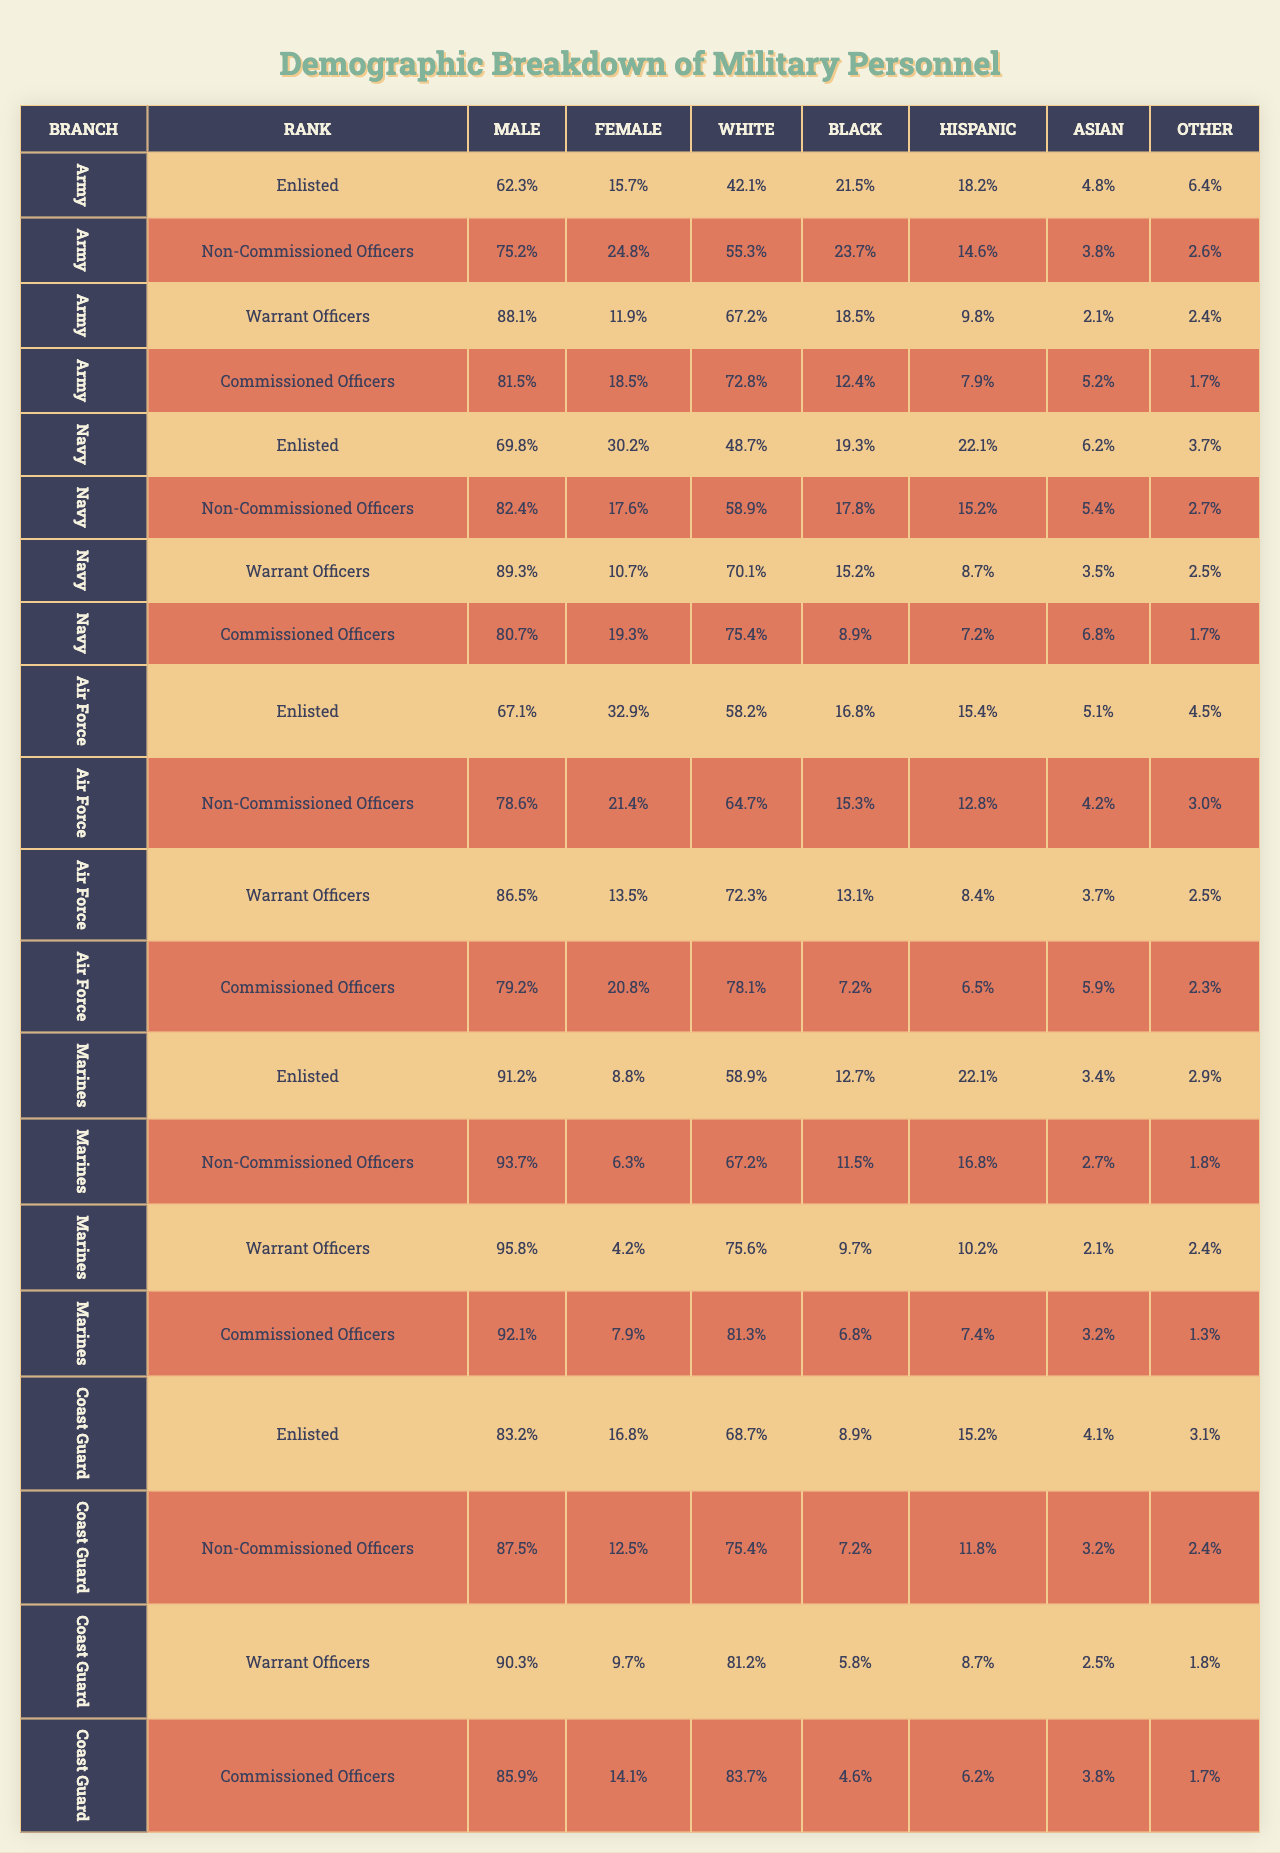What percentage of Army personnel are Female in the Enlisted rank? In the table under the Army branch and Enlisted rank, the Female percentage is 15.7%.
Answer: 15.7% Which branch has the highest percentage of Male personnel in the Warrant Officers rank? From the table, the Marines have the highest Male percentage in the Warrant Officers rank with 95.8%.
Answer: 95.8% Is the percentage of White personnel in the Navy higher than in the Coast Guard in the Non-Commissioned Officers rank? For Non-Commissioned Officers, the Navy has 58.9% White personnel while the Coast Guard has 75.4%. Therefore, this statement is false.
Answer: No Which rank in the Army has the lowest percentage of Female personnel? In the Army, the Warrant Officers rank has the lowest Female percentage at 11.9%.
Answer: 11.9% What is the combined percentage of Black and Hispanic personnel in the Air Force's Enlisted rank? The Enlisted rank in the Air Force has 16.8% Black and 15.4% Hispanic. Adding these gives 16.8% + 15.4% = 32.2%.
Answer: 32.2% Does the Coast Guard have a higher percentage of Females in Commissioned Officers compared to the Air Force? The Coast Guard has 14.1% Female in Commissioned Officers, while the Air Force has 20.8%. This means the Coast Guard has a lower percentage, so the statement is false.
Answer: No What is the average percentage of Male personnel across all branches for Non-Commissioned Officers? The averages for the Male percentages are: Army: 75.2%, Navy: 82.4%, Air Force: 78.6%, Marines: 93.7%, Coast Guard: 87.5%. Summing those up gives 75.2 + 82.4 + 78.6 + 93.7 + 87.5 = 417.4%. Dividing by 5 gives an average of 83.5%.
Answer: 83.5% Which branch has the highest percentage of Hispanic personnel in the Enlisted rank? The highest Hispanic percentage in the Enlisted rank is in the Marines with 22.1%.
Answer: 22.1% What is the difference in Male personnel percentage between the highest and lowest percentages in the Commissioned Officers rank? The highest is in the Marines at 92.1% and the lowest is in the Air Force at 79.2%. The difference is 92.1% - 79.2% = 12.9%.
Answer: 12.9% Are there any branches where Black personnel exceed 20% in the Commissioned Officers rank? In the Commissioned Officers rank, the Army has 12.4% Black personnel, the Navy has 8.9%, the Air Force has 7.2%, the Marines have 6.8%, and the Coast Guard has 4.6%. None exceed 20%, so the statement is false.
Answer: No 